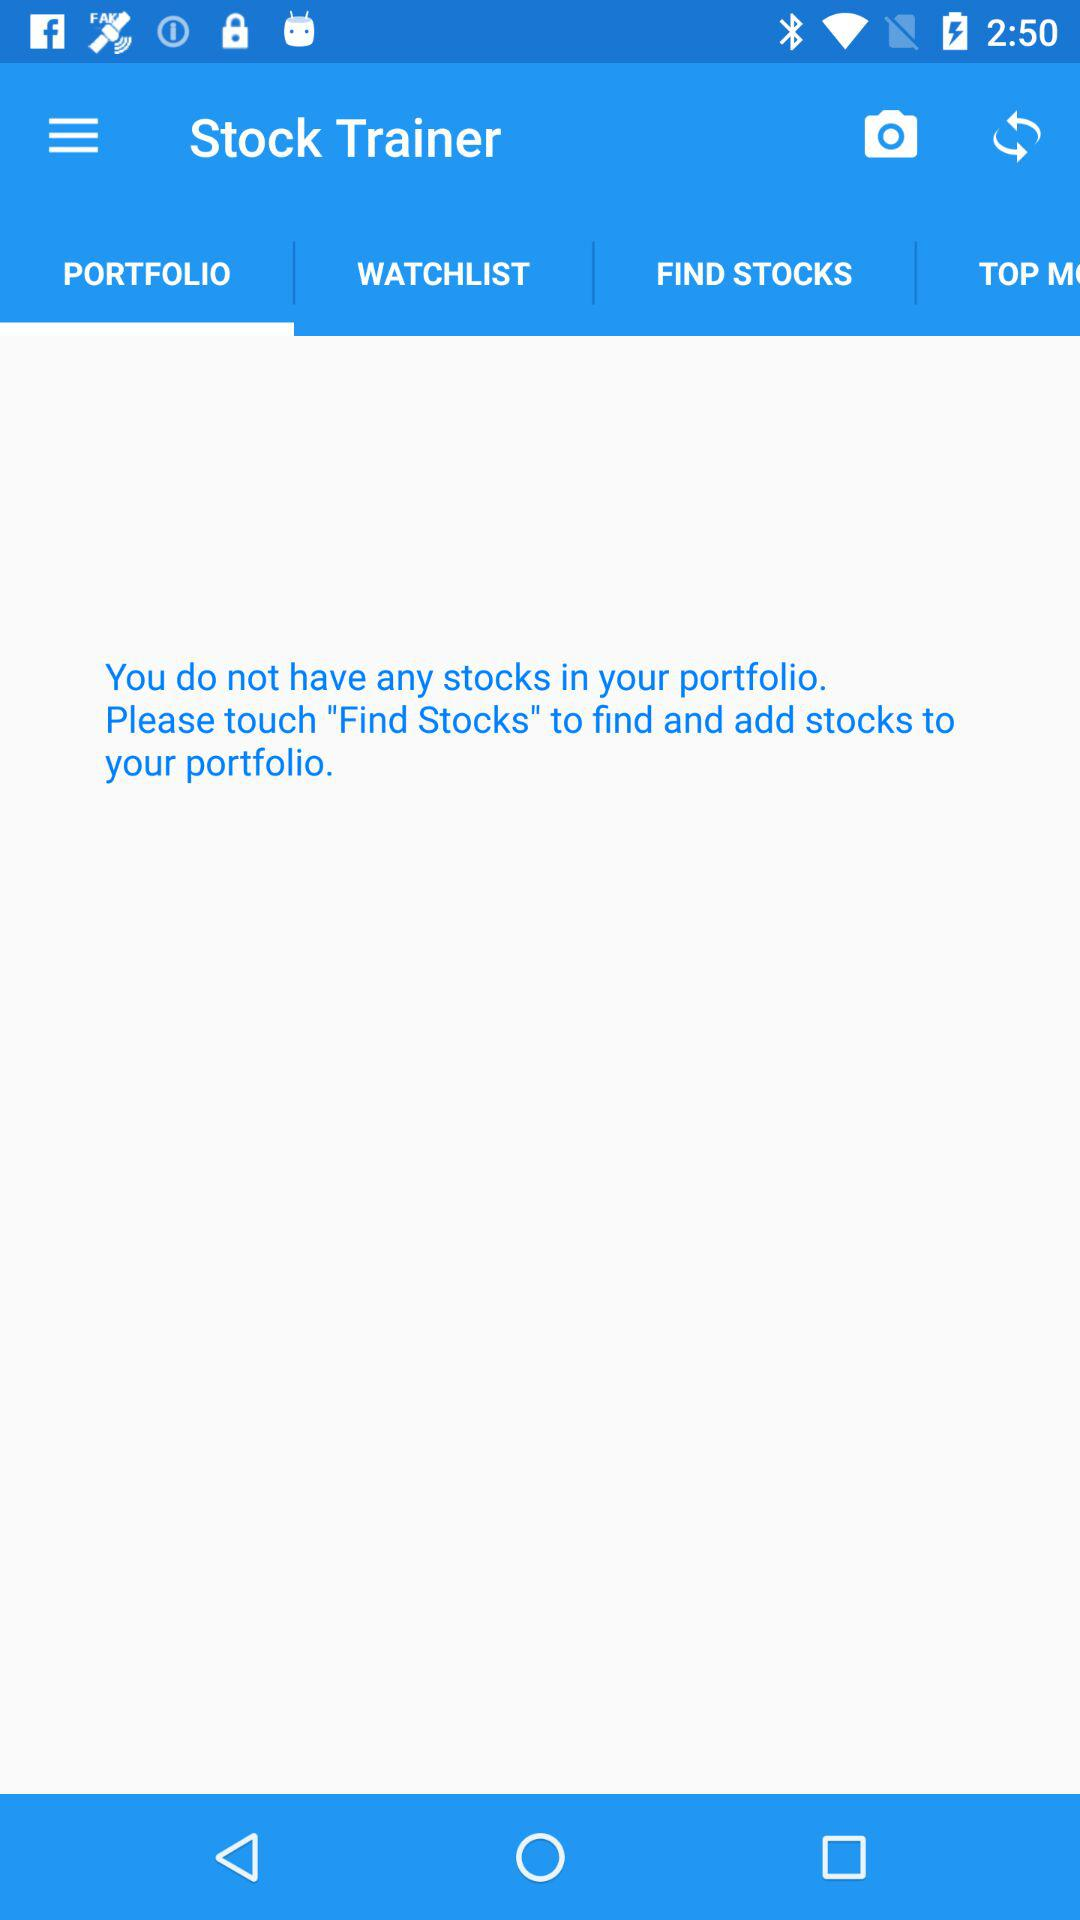How many stocks are there in the portfolio?
When the provided information is insufficient, respond with <no answer>. <no answer> 